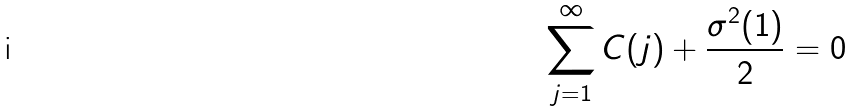<formula> <loc_0><loc_0><loc_500><loc_500>\sum _ { j = 1 } ^ { \infty } C ( j ) + \frac { \sigma ^ { 2 } ( 1 ) } { 2 } = 0</formula> 